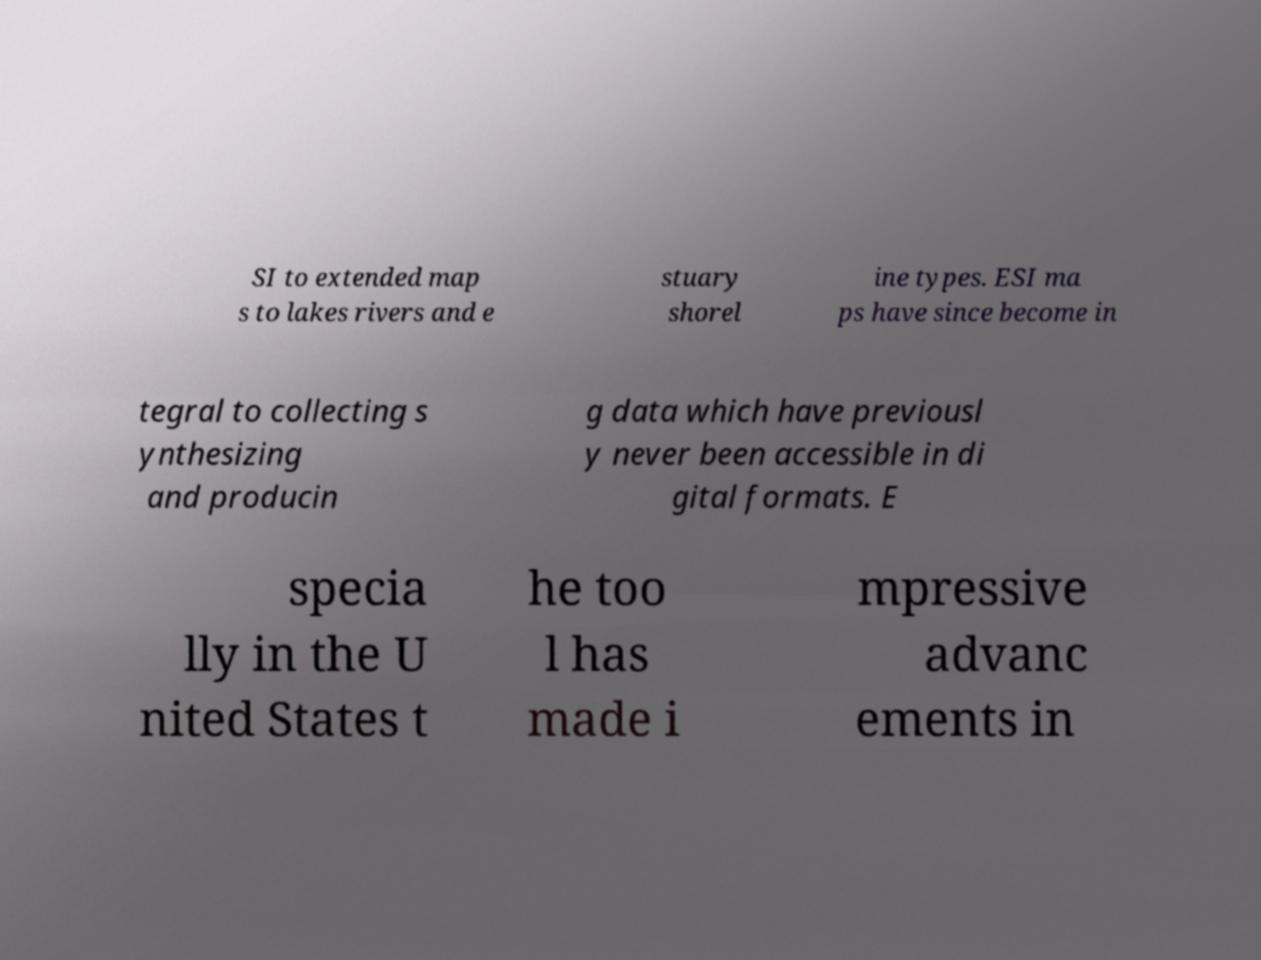Can you read and provide the text displayed in the image?This photo seems to have some interesting text. Can you extract and type it out for me? SI to extended map s to lakes rivers and e stuary shorel ine types. ESI ma ps have since become in tegral to collecting s ynthesizing and producin g data which have previousl y never been accessible in di gital formats. E specia lly in the U nited States t he too l has made i mpressive advanc ements in 